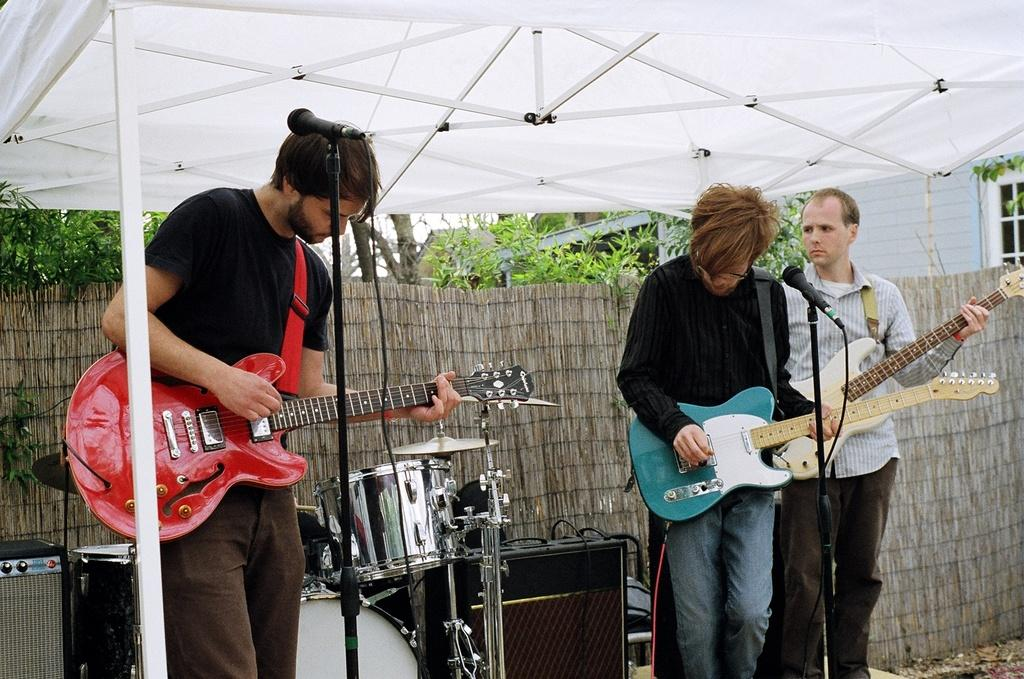How many people are in the image? There are three people in the image. What are the people doing in the image? The people are standing and holding guitars. What is in front of the people? There are mice in front of the people. What can be seen in the background of the image? There is a drum set, trees, and a building in the background of the image. What type of wristwatch is the person on the left wearing in the image? There is no wristwatch visible on any of the people in the image. 